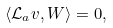Convert formula to latex. <formula><loc_0><loc_0><loc_500><loc_500>\langle \mathcal { L } _ { a } v , W \rangle = 0 ,</formula> 